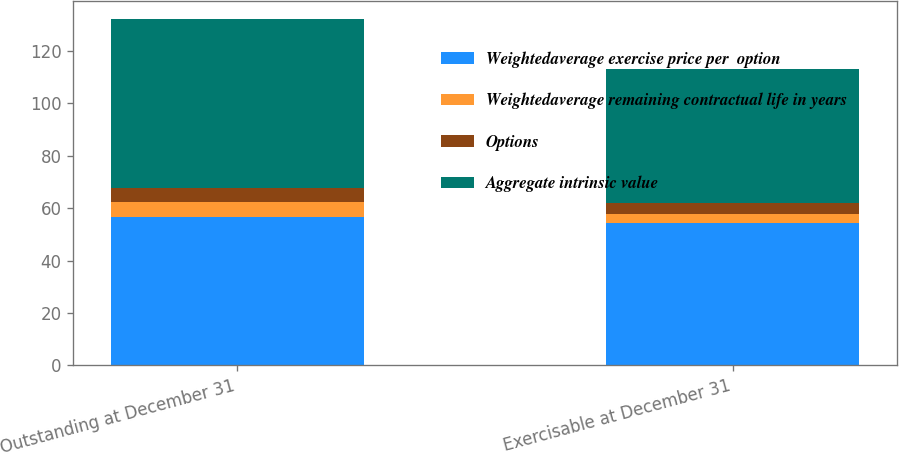Convert chart to OTSL. <chart><loc_0><loc_0><loc_500><loc_500><stacked_bar_chart><ecel><fcel>Outstanding at December 31<fcel>Exercisable at December 31<nl><fcel>Weightedaverage exercise price per  option<fcel>56.75<fcel>54.28<nl><fcel>Weightedaverage remaining contractual life in years<fcel>5.5<fcel>3.7<nl><fcel>Options<fcel>5.6<fcel>4<nl><fcel>Aggregate intrinsic value<fcel>64.5<fcel>51.3<nl></chart> 